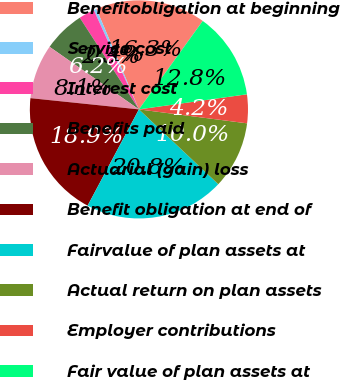Convert chart to OTSL. <chart><loc_0><loc_0><loc_500><loc_500><pie_chart><fcel>Benefitobligation at beginning<fcel>Service cost<fcel>Interest cost<fcel>Benefits paid<fcel>Actuarial (gain) loss<fcel>Benefit obligation at end of<fcel>Fairvalue of plan assets at<fcel>Actual return on plan assets<fcel>Employer contributions<fcel>Fair value of plan assets at<nl><fcel>16.32%<fcel>0.42%<fcel>2.33%<fcel>6.16%<fcel>8.08%<fcel>18.85%<fcel>20.76%<fcel>9.99%<fcel>4.25%<fcel>12.84%<nl></chart> 